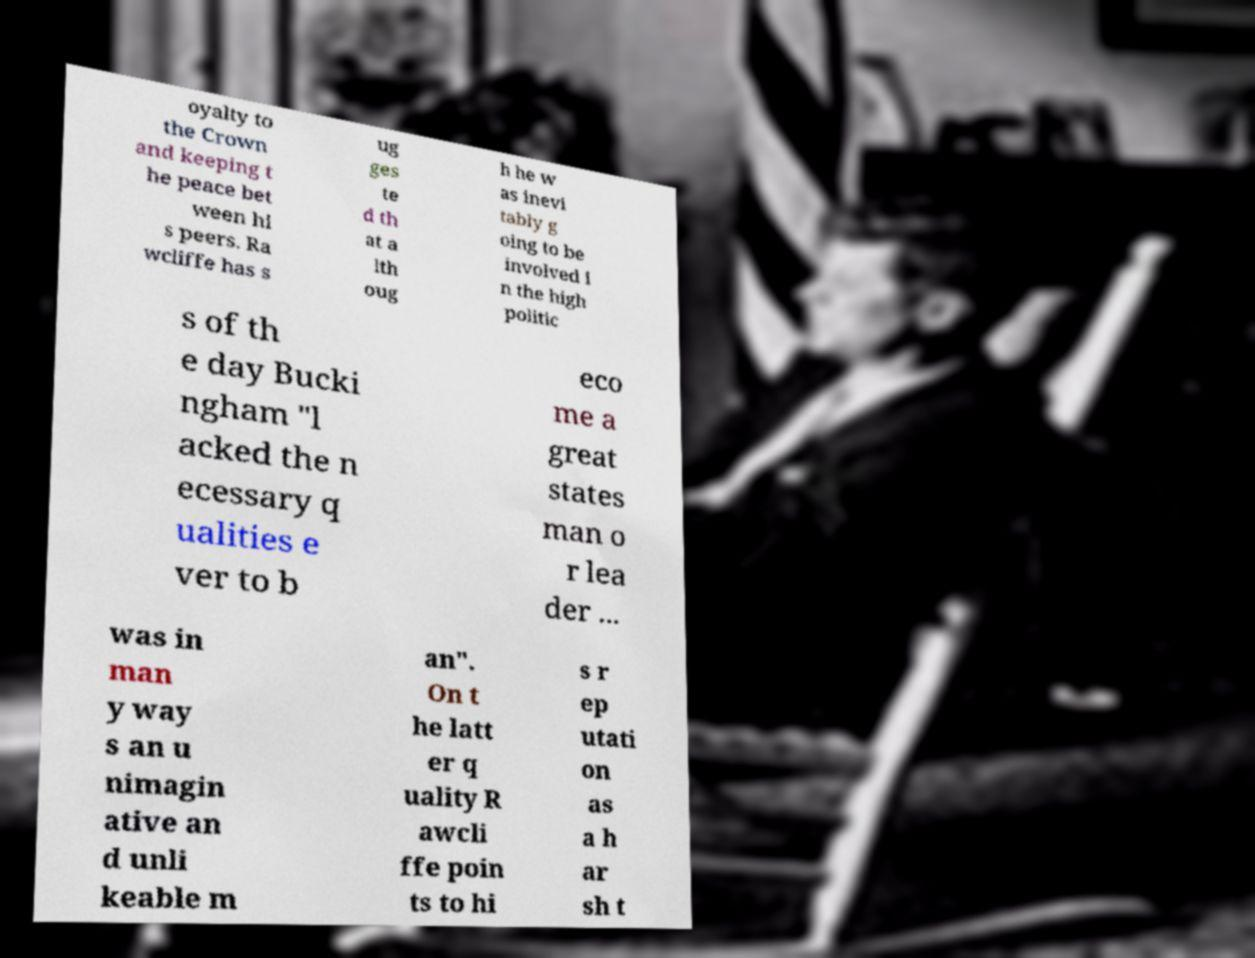There's text embedded in this image that I need extracted. Can you transcribe it verbatim? oyalty to the Crown and keeping t he peace bet ween hi s peers. Ra wcliffe has s ug ges te d th at a lth oug h he w as inevi tably g oing to be involved i n the high politic s of th e day Bucki ngham "l acked the n ecessary q ualities e ver to b eco me a great states man o r lea der ... was in man y way s an u nimagin ative an d unli keable m an". On t he latt er q uality R awcli ffe poin ts to hi s r ep utati on as a h ar sh t 